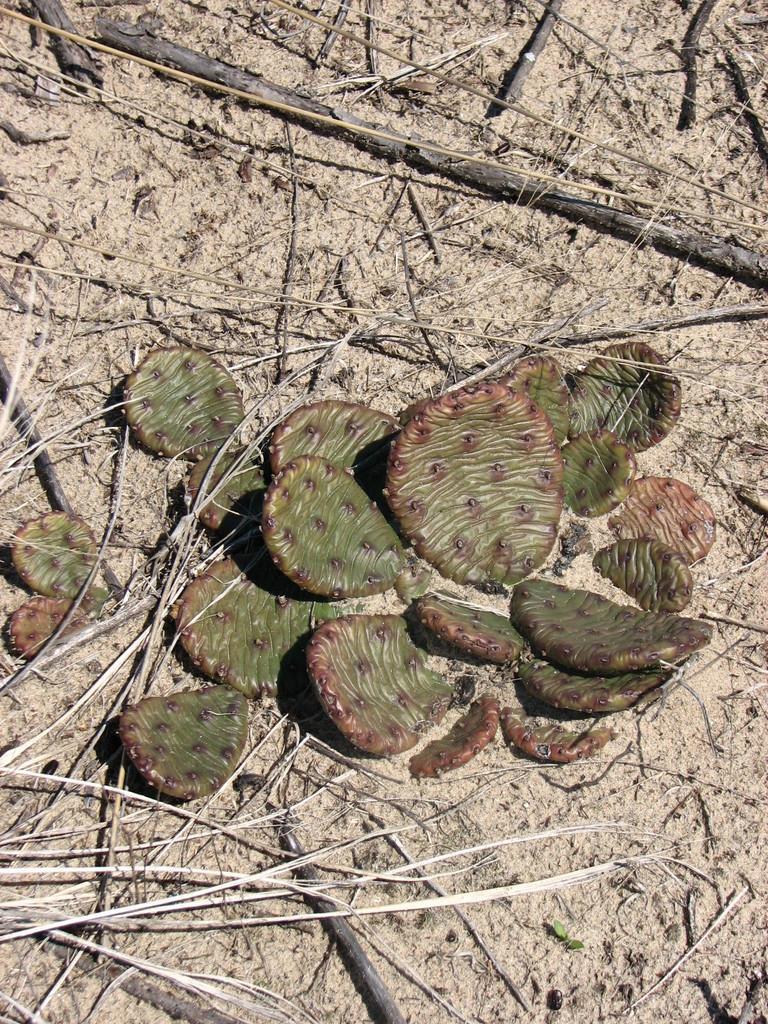Could you give a brief overview of what you see in this image? There are some pieces of a dry cactus on the ground as we can see in the middle of this image. 